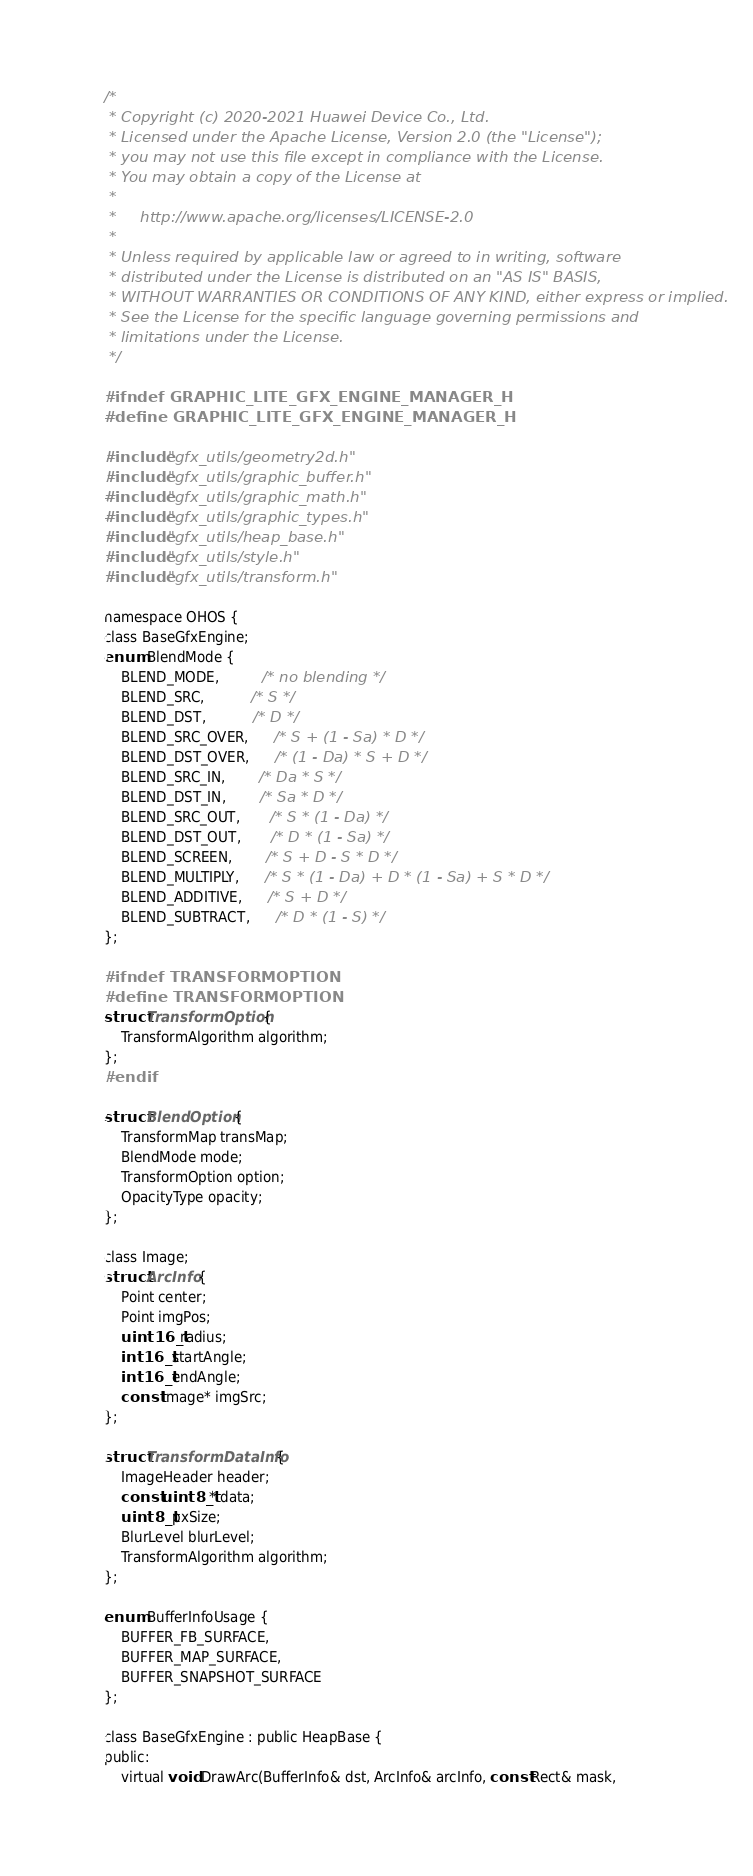Convert code to text. <code><loc_0><loc_0><loc_500><loc_500><_C_>/*
 * Copyright (c) 2020-2021 Huawei Device Co., Ltd.
 * Licensed under the Apache License, Version 2.0 (the "License");
 * you may not use this file except in compliance with the License.
 * You may obtain a copy of the License at
 *
 *     http://www.apache.org/licenses/LICENSE-2.0
 *
 * Unless required by applicable law or agreed to in writing, software
 * distributed under the License is distributed on an "AS IS" BASIS,
 * WITHOUT WARRANTIES OR CONDITIONS OF ANY KIND, either express or implied.
 * See the License for the specific language governing permissions and
 * limitations under the License.
 */

#ifndef GRAPHIC_LITE_GFX_ENGINE_MANAGER_H
#define GRAPHIC_LITE_GFX_ENGINE_MANAGER_H

#include "gfx_utils/geometry2d.h"
#include "gfx_utils/graphic_buffer.h"
#include "gfx_utils/graphic_math.h"
#include "gfx_utils/graphic_types.h"
#include "gfx_utils/heap_base.h"
#include "gfx_utils/style.h"
#include "gfx_utils/transform.h"

namespace OHOS {
class BaseGfxEngine;
enum BlendMode {
    BLEND_MODE,          /* no blending */
    BLEND_SRC,           /* S */
    BLEND_DST,           /* D */
    BLEND_SRC_OVER,      /* S + (1 - Sa) * D */
    BLEND_DST_OVER,      /* (1 - Da) * S + D */
    BLEND_SRC_IN,        /* Da * S */
    BLEND_DST_IN,        /* Sa * D */
    BLEND_SRC_OUT,       /* S * (1 - Da) */
    BLEND_DST_OUT,       /* D * (1 - Sa) */
    BLEND_SCREEN,        /* S + D - S * D */
    BLEND_MULTIPLY,      /* S * (1 - Da) + D * (1 - Sa) + S * D */
    BLEND_ADDITIVE,      /* S + D */
    BLEND_SUBTRACT,      /* D * (1 - S) */
};

#ifndef TRANSFORMOPTION
#define TRANSFORMOPTION
struct TransformOption {
    TransformAlgorithm algorithm;
};
#endif

struct BlendOption {
    TransformMap transMap;
    BlendMode mode;
    TransformOption option;
    OpacityType opacity;
};

class Image;
struct ArcInfo {
    Point center;
    Point imgPos;
    uint16_t radius;
    int16_t startAngle;
    int16_t endAngle;
    const Image* imgSrc;
};

struct TransformDataInfo {
    ImageHeader header;
    const uint8_t* data;
    uint8_t pxSize;
    BlurLevel blurLevel;
    TransformAlgorithm algorithm;
};

enum BufferInfoUsage {
    BUFFER_FB_SURFACE,
    BUFFER_MAP_SURFACE,
    BUFFER_SNAPSHOT_SURFACE
};

class BaseGfxEngine : public HeapBase {
public:
    virtual void DrawArc(BufferInfo& dst, ArcInfo& arcInfo, const Rect& mask,</code> 